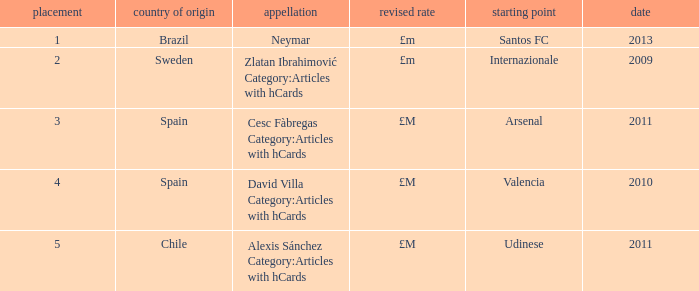Where is the ranked 2 players from? Internazionale. Would you mind parsing the complete table? {'header': ['placement', 'country of origin', 'appellation', 'revised rate', 'starting point', 'date'], 'rows': [['1', 'Brazil', 'Neymar', '£m', 'Santos FC', '2013'], ['2', 'Sweden', 'Zlatan Ibrahimović Category:Articles with hCards', '£m', 'Internazionale', '2009'], ['3', 'Spain', 'Cesc Fàbregas Category:Articles with hCards', '£M', 'Arsenal', '2011'], ['4', 'Spain', 'David Villa Category:Articles with hCards', '£M', 'Valencia', '2010'], ['5', 'Chile', 'Alexis Sánchez Category:Articles with hCards', '£M', 'Udinese', '2011']]} 